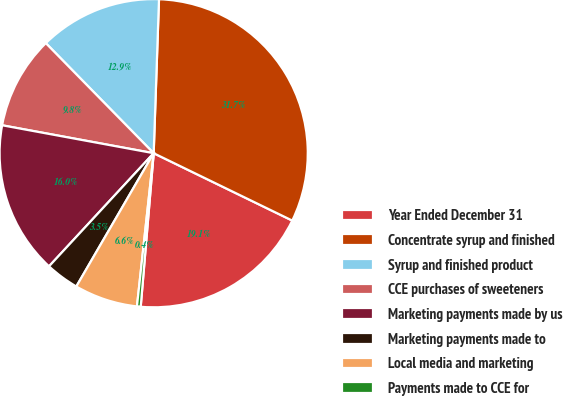<chart> <loc_0><loc_0><loc_500><loc_500><pie_chart><fcel>Year Ended December 31<fcel>Concentrate syrup and finished<fcel>Syrup and finished product<fcel>CCE purchases of sweeteners<fcel>Marketing payments made by us<fcel>Marketing payments made to<fcel>Local media and marketing<fcel>Payments made to CCE for<nl><fcel>19.14%<fcel>31.65%<fcel>12.89%<fcel>9.76%<fcel>16.02%<fcel>3.51%<fcel>6.64%<fcel>0.39%<nl></chart> 